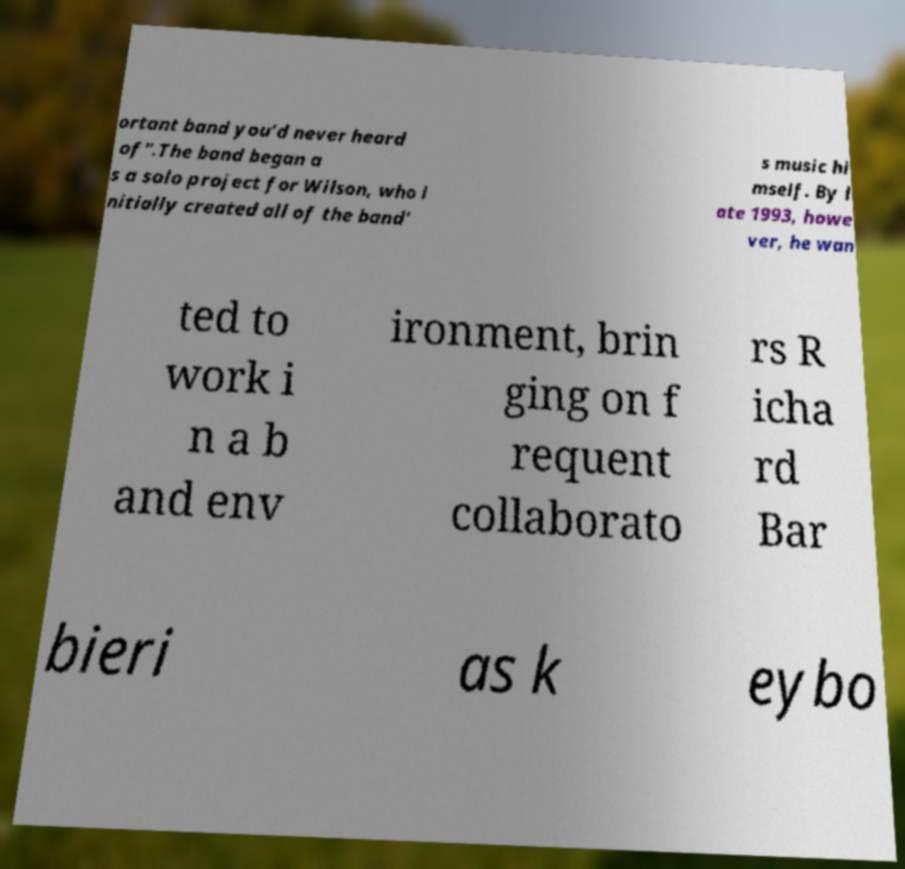I need the written content from this picture converted into text. Can you do that? ortant band you’d never heard of".The band began a s a solo project for Wilson, who i nitially created all of the band' s music hi mself. By l ate 1993, howe ver, he wan ted to work i n a b and env ironment, brin ging on f requent collaborato rs R icha rd Bar bieri as k eybo 